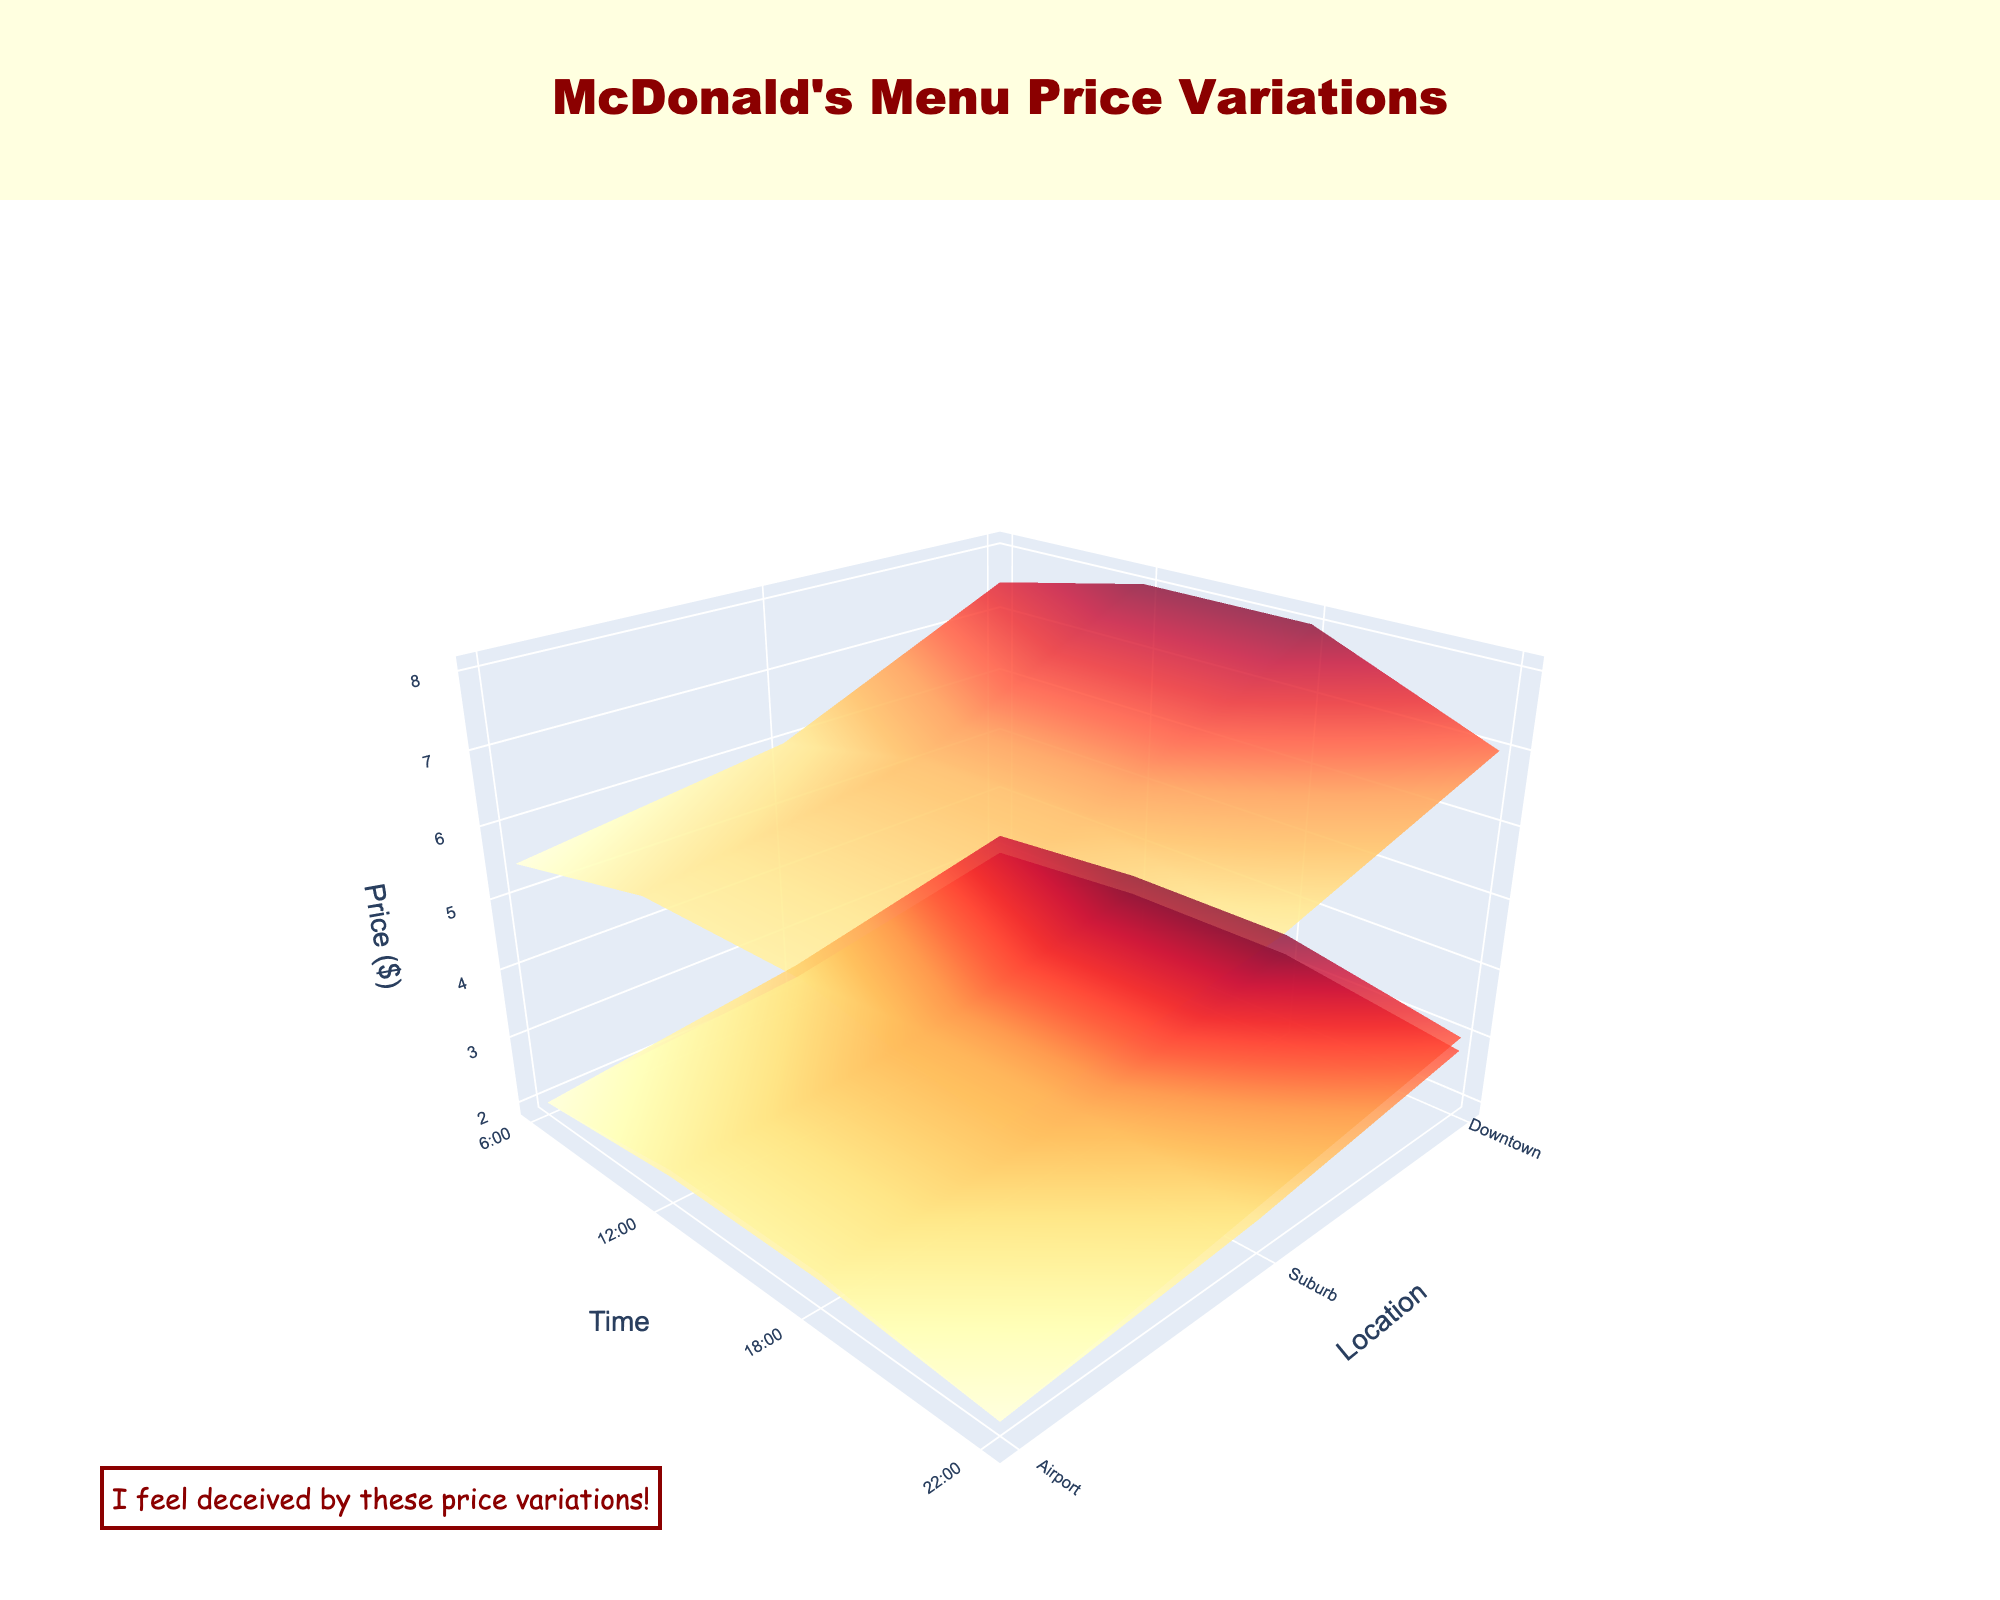What's the title of the plot? The title is prominently displayed at the top of the plot.
Answer: McDonald's Menu Price Variations What is the price of a Big Mac at the Airport at 6:00? Look at the segment where the location is Airport and the time is 6:00; observe the corresponding point on the surface plot for Big Mac.
Answer: $6.99 At what time is the price of French Fries more expensive at the Airport compared to Downtown? Find the times when the price surface for French Fries is higher at the Airport point than at the Downtown point. Compare the z-axis values for both points.
Answer: 6:00, 12:00, 18:00, 22:00 Which menu item shows the highest price variation across locations at 18:00? Compare the relative heights of the surfaces for each menu item at the given time. Identify which item's surface shows the most vertical difference across locations.
Answer: Big Mac Do McChicken prices vary more by location or by time of day? Observe the surface plot for McChicken. If the surface has more vertical variation across the x-axis (location) than the y-axis (time), then it varies more by location. Otherwise, it varies more by time.
Answer: By location What is the difference in the price of a Big Mac between Downtown and the Airport at 18:00? Identify the heights of the Big Mac surface at Downtown and Airport for the 18:00 time point and compute the difference. Downtown price is $6.49, Airport is $7.99.
Answer: $1.50 At which location does the price of French Fries remain constant throughout the day? Look at the French Fries surface and identify any location where the z-axis values (prices) are constant across all times.
Answer: Suburb Is there any time when the McChicken at the Airport is cheaper than at Downtown? Compare the heights (prices) of the McChicken surface at Airport and Downtown for each time point.
Answer: No What's the average price of a Big Mac in the Suburb across all times? Summarize the prices in Suburb for the given menu item and divide by the number of time points. The prices are $5.49, $5.49, $5.99, and $5.99. Average = (5.49 + 5.49 + 5.99 + 5.99) / 4 = $5.74.
Answer: $5.74 Which location and time combination has the highest overall price for a McChicken? Examine the McChicken surface and find the point with the highest value.
Answer: 12:00 at Airport 